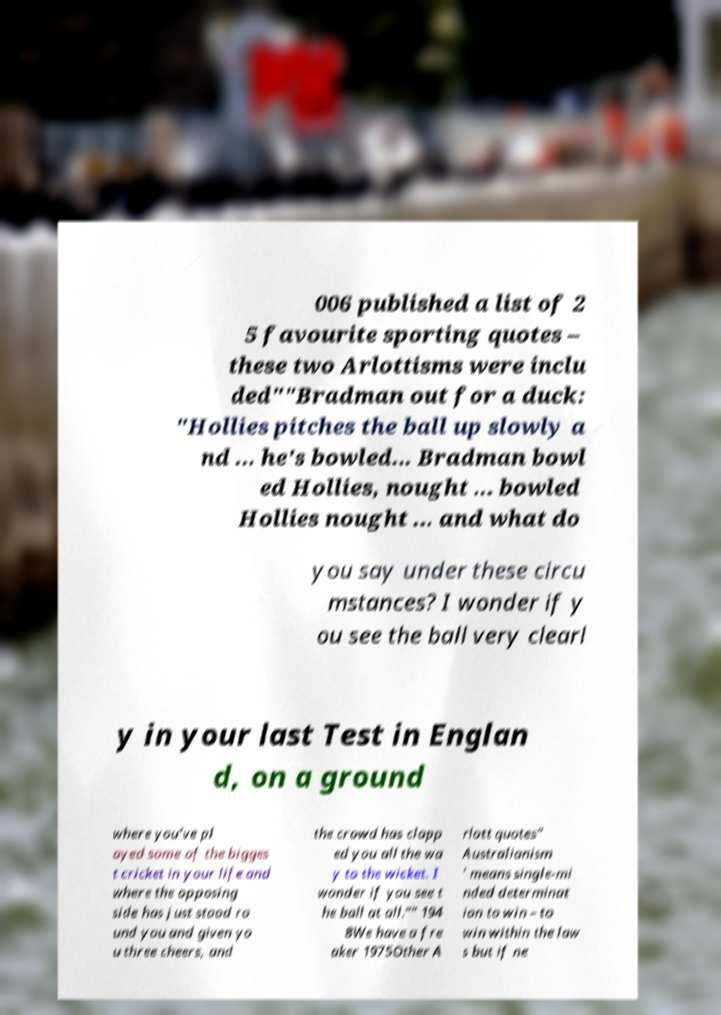What messages or text are displayed in this image? I need them in a readable, typed format. 006 published a list of 2 5 favourite sporting quotes – these two Arlottisms were inclu ded""Bradman out for a duck: "Hollies pitches the ball up slowly a nd ... he's bowled... Bradman bowl ed Hollies, nought ... bowled Hollies nought ... and what do you say under these circu mstances? I wonder if y ou see the ball very clearl y in your last Test in Englan d, on a ground where you've pl ayed some of the bigges t cricket in your life and where the opposing side has just stood ro und you and given yo u three cheers, and the crowd has clapp ed you all the wa y to the wicket. I wonder if you see t he ball at all."" 194 8We have a fre aker 1975Other A rlott quotes" Australianism ' means single-mi nded determinat ion to win – to win within the law s but if ne 